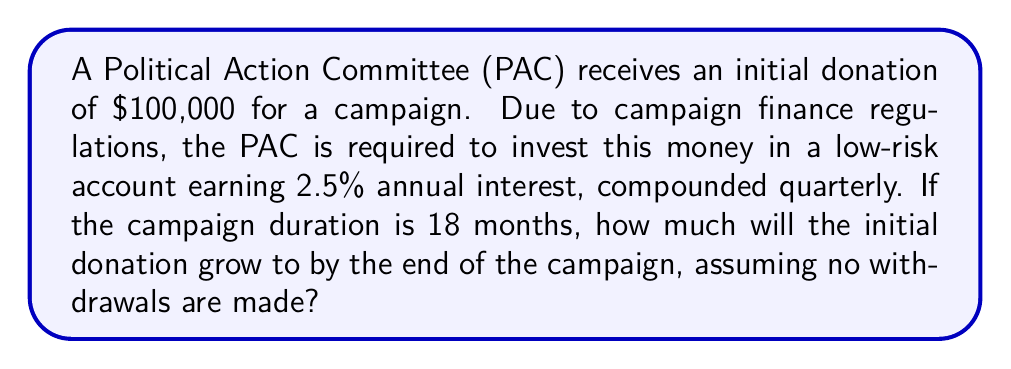Give your solution to this math problem. To solve this problem, we'll use the compound interest formula:

$$A = P(1 + \frac{r}{n})^{nt}$$

Where:
$A$ = Final amount
$P$ = Principal (initial investment)
$r$ = Annual interest rate (as a decimal)
$n$ = Number of times interest is compounded per year
$t$ = Number of years

Given:
$P = \$100,000$
$r = 0.025$ (2.5% expressed as a decimal)
$n = 4$ (compounded quarterly)
$t = 1.5$ (18 months = 1.5 years)

Let's substitute these values into the formula:

$$A = 100,000(1 + \frac{0.025}{4})^{4(1.5)}$$

$$A = 100,000(1 + 0.00625)^6$$

$$A = 100,000(1.00625)^6$$

Using a calculator or computer:

$$A = 100,000 * 1.0380741$$

$$A = 103,807.41$$
Answer: $103,807.41 